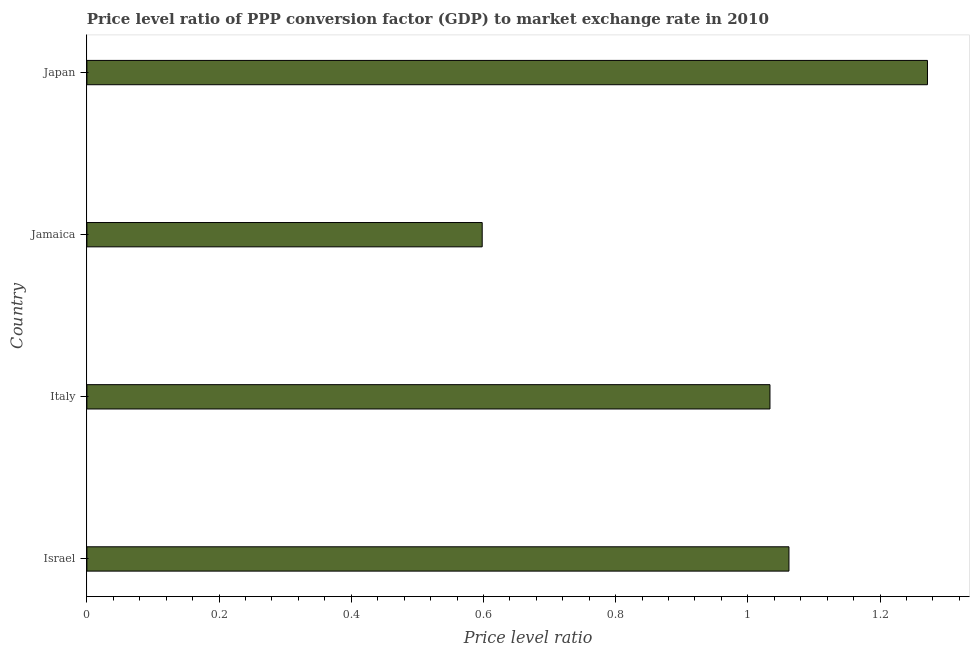Does the graph contain any zero values?
Offer a terse response. No. What is the title of the graph?
Make the answer very short. Price level ratio of PPP conversion factor (GDP) to market exchange rate in 2010. What is the label or title of the X-axis?
Offer a terse response. Price level ratio. What is the price level ratio in Italy?
Provide a succinct answer. 1.03. Across all countries, what is the maximum price level ratio?
Ensure brevity in your answer.  1.27. Across all countries, what is the minimum price level ratio?
Offer a terse response. 0.6. In which country was the price level ratio maximum?
Provide a succinct answer. Japan. In which country was the price level ratio minimum?
Your answer should be compact. Jamaica. What is the sum of the price level ratio?
Ensure brevity in your answer.  3.97. What is the difference between the price level ratio in Jamaica and Japan?
Your response must be concise. -0.67. What is the average price level ratio per country?
Your answer should be compact. 0.99. What is the median price level ratio?
Provide a short and direct response. 1.05. In how many countries, is the price level ratio greater than 0.88 ?
Your answer should be compact. 3. What is the ratio of the price level ratio in Israel to that in Jamaica?
Provide a succinct answer. 1.78. What is the difference between the highest and the second highest price level ratio?
Provide a short and direct response. 0.21. Is the sum of the price level ratio in Jamaica and Japan greater than the maximum price level ratio across all countries?
Make the answer very short. Yes. What is the difference between the highest and the lowest price level ratio?
Your answer should be very brief. 0.67. In how many countries, is the price level ratio greater than the average price level ratio taken over all countries?
Your answer should be very brief. 3. Are all the bars in the graph horizontal?
Offer a terse response. Yes. What is the difference between two consecutive major ticks on the X-axis?
Give a very brief answer. 0.2. Are the values on the major ticks of X-axis written in scientific E-notation?
Offer a terse response. No. What is the Price level ratio in Israel?
Ensure brevity in your answer.  1.06. What is the Price level ratio in Italy?
Provide a short and direct response. 1.03. What is the Price level ratio in Jamaica?
Provide a succinct answer. 0.6. What is the Price level ratio of Japan?
Provide a succinct answer. 1.27. What is the difference between the Price level ratio in Israel and Italy?
Your response must be concise. 0.03. What is the difference between the Price level ratio in Israel and Jamaica?
Your answer should be very brief. 0.46. What is the difference between the Price level ratio in Israel and Japan?
Give a very brief answer. -0.21. What is the difference between the Price level ratio in Italy and Jamaica?
Your answer should be very brief. 0.44. What is the difference between the Price level ratio in Italy and Japan?
Your answer should be very brief. -0.24. What is the difference between the Price level ratio in Jamaica and Japan?
Your response must be concise. -0.67. What is the ratio of the Price level ratio in Israel to that in Italy?
Offer a very short reply. 1.03. What is the ratio of the Price level ratio in Israel to that in Jamaica?
Keep it short and to the point. 1.78. What is the ratio of the Price level ratio in Israel to that in Japan?
Your response must be concise. 0.83. What is the ratio of the Price level ratio in Italy to that in Jamaica?
Make the answer very short. 1.73. What is the ratio of the Price level ratio in Italy to that in Japan?
Make the answer very short. 0.81. What is the ratio of the Price level ratio in Jamaica to that in Japan?
Offer a very short reply. 0.47. 